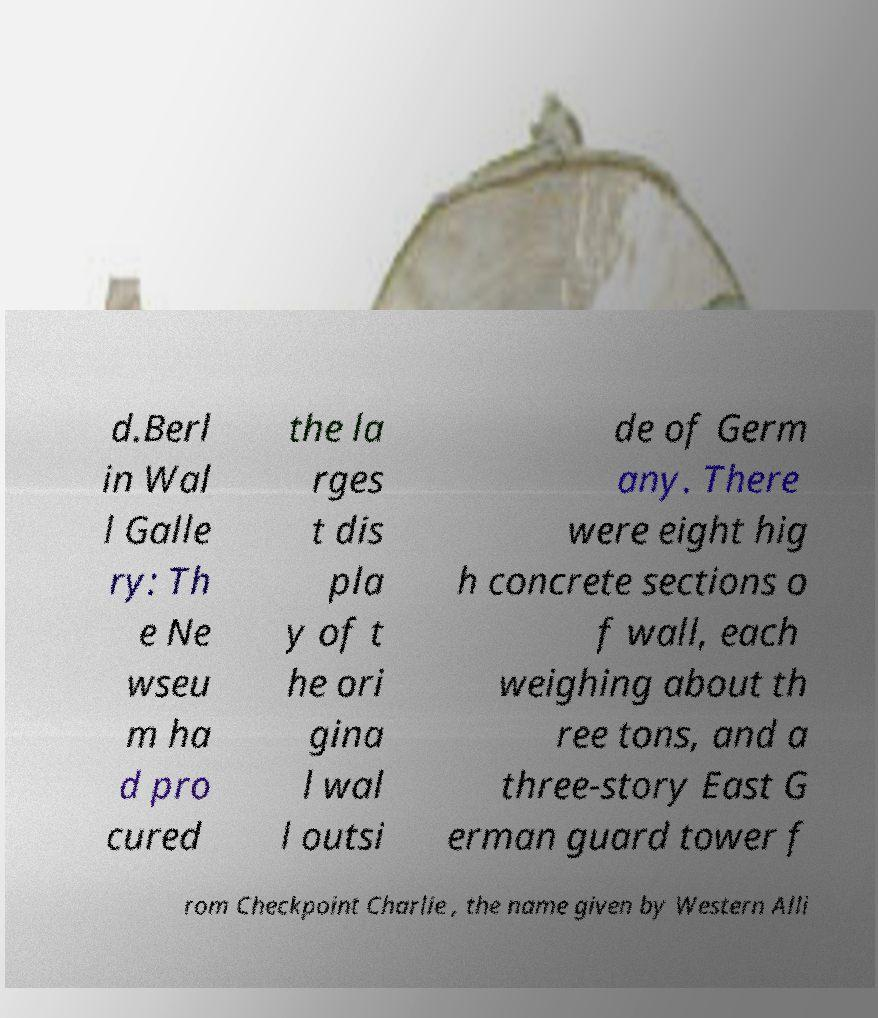Can you read and provide the text displayed in the image?This photo seems to have some interesting text. Can you extract and type it out for me? d.Berl in Wal l Galle ry: Th e Ne wseu m ha d pro cured the la rges t dis pla y of t he ori gina l wal l outsi de of Germ any. There were eight hig h concrete sections o f wall, each weighing about th ree tons, and a three-story East G erman guard tower f rom Checkpoint Charlie , the name given by Western Alli 